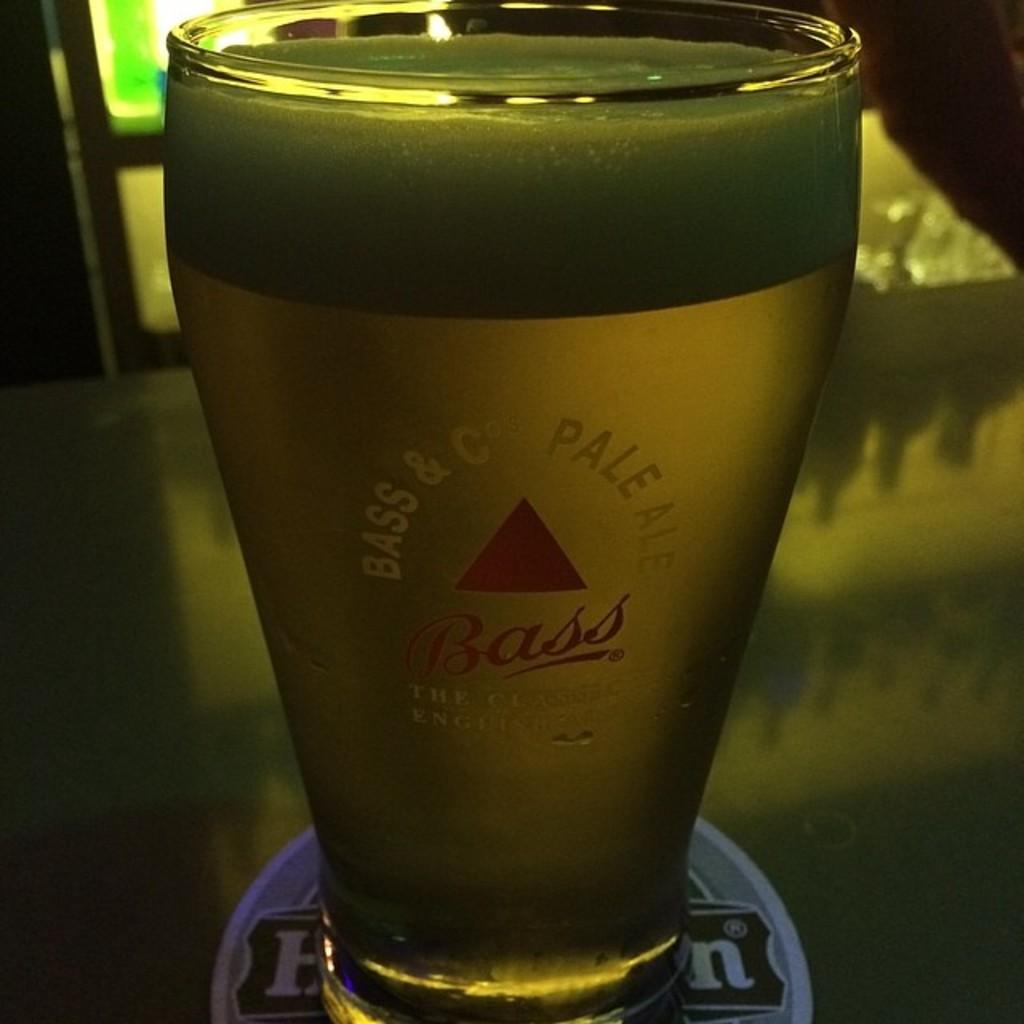<image>
Render a clear and concise summary of the photo. A full glass of beer in a dark room made by the Bass & Pale Ale company. 